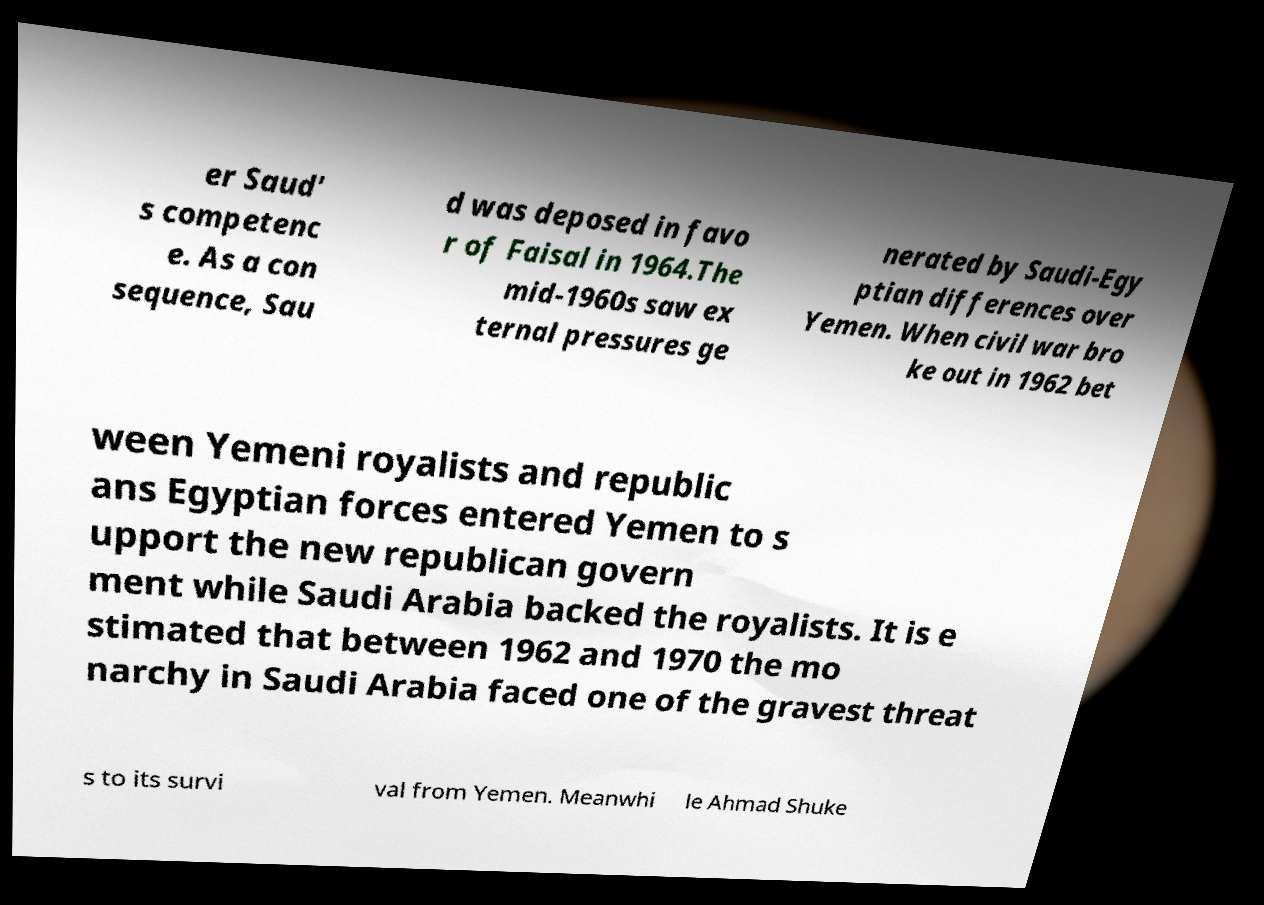Please read and relay the text visible in this image. What does it say? er Saud' s competenc e. As a con sequence, Sau d was deposed in favo r of Faisal in 1964.The mid-1960s saw ex ternal pressures ge nerated by Saudi-Egy ptian differences over Yemen. When civil war bro ke out in 1962 bet ween Yemeni royalists and republic ans Egyptian forces entered Yemen to s upport the new republican govern ment while Saudi Arabia backed the royalists. It is e stimated that between 1962 and 1970 the mo narchy in Saudi Arabia faced one of the gravest threat s to its survi val from Yemen. Meanwhi le Ahmad Shuke 